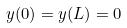<formula> <loc_0><loc_0><loc_500><loc_500>y ( 0 ) = y ( L ) = 0</formula> 